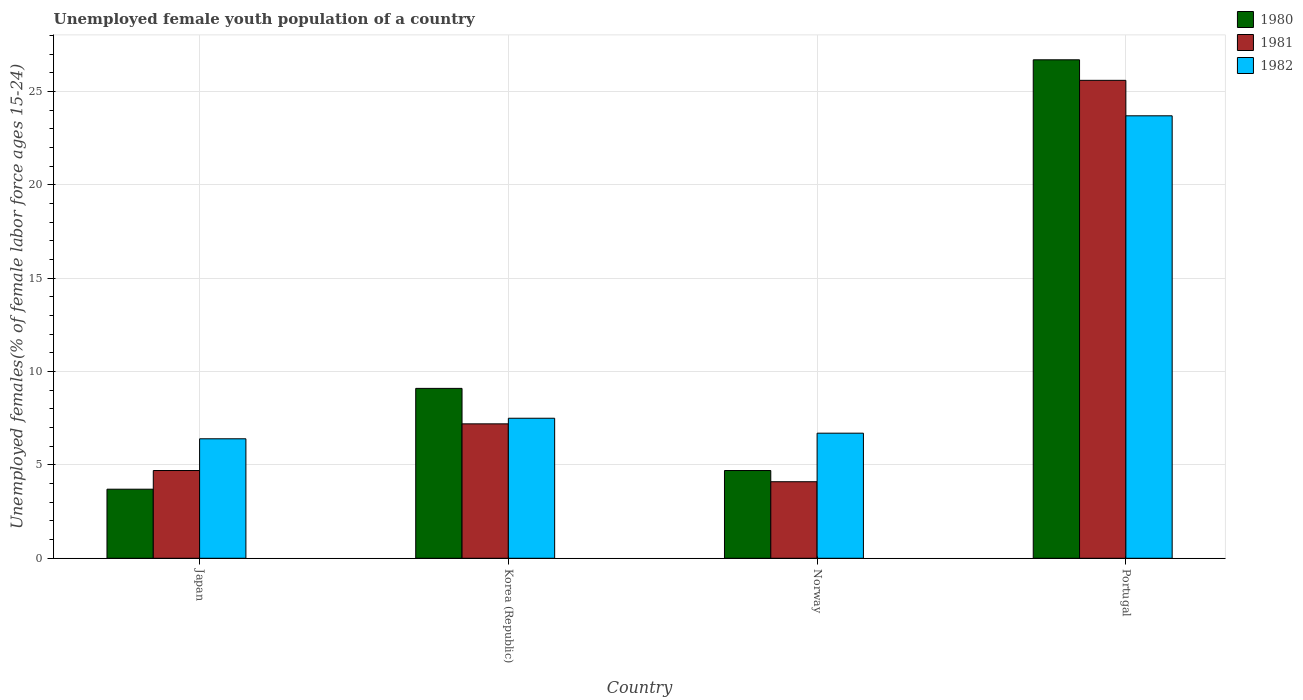How many different coloured bars are there?
Make the answer very short. 3. How many groups of bars are there?
Offer a very short reply. 4. Are the number of bars per tick equal to the number of legend labels?
Offer a very short reply. Yes. How many bars are there on the 2nd tick from the left?
Your response must be concise. 3. What is the percentage of unemployed female youth population in 1981 in Japan?
Provide a short and direct response. 4.7. Across all countries, what is the maximum percentage of unemployed female youth population in 1981?
Keep it short and to the point. 25.6. Across all countries, what is the minimum percentage of unemployed female youth population in 1982?
Offer a very short reply. 6.4. In which country was the percentage of unemployed female youth population in 1982 maximum?
Provide a short and direct response. Portugal. What is the total percentage of unemployed female youth population in 1981 in the graph?
Your answer should be very brief. 41.6. What is the difference between the percentage of unemployed female youth population in 1981 in Korea (Republic) and that in Portugal?
Keep it short and to the point. -18.4. What is the difference between the percentage of unemployed female youth population in 1982 in Norway and the percentage of unemployed female youth population in 1981 in Portugal?
Provide a short and direct response. -18.9. What is the average percentage of unemployed female youth population in 1980 per country?
Offer a very short reply. 11.05. What is the difference between the percentage of unemployed female youth population of/in 1980 and percentage of unemployed female youth population of/in 1981 in Portugal?
Offer a terse response. 1.1. In how many countries, is the percentage of unemployed female youth population in 1982 greater than 25 %?
Provide a short and direct response. 0. What is the ratio of the percentage of unemployed female youth population in 1982 in Norway to that in Portugal?
Ensure brevity in your answer.  0.28. Is the difference between the percentage of unemployed female youth population in 1980 in Japan and Norway greater than the difference between the percentage of unemployed female youth population in 1981 in Japan and Norway?
Make the answer very short. No. What is the difference between the highest and the second highest percentage of unemployed female youth population in 1981?
Provide a short and direct response. 20.9. What is the difference between the highest and the lowest percentage of unemployed female youth population in 1980?
Your answer should be very brief. 23. In how many countries, is the percentage of unemployed female youth population in 1980 greater than the average percentage of unemployed female youth population in 1980 taken over all countries?
Your answer should be compact. 1. What does the 1st bar from the right in Japan represents?
Ensure brevity in your answer.  1982. How many bars are there?
Make the answer very short. 12. Are all the bars in the graph horizontal?
Your response must be concise. No. What is the difference between two consecutive major ticks on the Y-axis?
Provide a short and direct response. 5. Does the graph contain any zero values?
Ensure brevity in your answer.  No. Where does the legend appear in the graph?
Ensure brevity in your answer.  Top right. What is the title of the graph?
Keep it short and to the point. Unemployed female youth population of a country. Does "1978" appear as one of the legend labels in the graph?
Offer a very short reply. No. What is the label or title of the X-axis?
Provide a short and direct response. Country. What is the label or title of the Y-axis?
Provide a short and direct response. Unemployed females(% of female labor force ages 15-24). What is the Unemployed females(% of female labor force ages 15-24) in 1980 in Japan?
Make the answer very short. 3.7. What is the Unemployed females(% of female labor force ages 15-24) in 1981 in Japan?
Provide a succinct answer. 4.7. What is the Unemployed females(% of female labor force ages 15-24) in 1982 in Japan?
Provide a short and direct response. 6.4. What is the Unemployed females(% of female labor force ages 15-24) of 1980 in Korea (Republic)?
Give a very brief answer. 9.1. What is the Unemployed females(% of female labor force ages 15-24) in 1981 in Korea (Republic)?
Ensure brevity in your answer.  7.2. What is the Unemployed females(% of female labor force ages 15-24) in 1980 in Norway?
Offer a very short reply. 4.7. What is the Unemployed females(% of female labor force ages 15-24) in 1981 in Norway?
Offer a terse response. 4.1. What is the Unemployed females(% of female labor force ages 15-24) in 1982 in Norway?
Make the answer very short. 6.7. What is the Unemployed females(% of female labor force ages 15-24) in 1980 in Portugal?
Provide a succinct answer. 26.7. What is the Unemployed females(% of female labor force ages 15-24) in 1981 in Portugal?
Your answer should be compact. 25.6. What is the Unemployed females(% of female labor force ages 15-24) in 1982 in Portugal?
Keep it short and to the point. 23.7. Across all countries, what is the maximum Unemployed females(% of female labor force ages 15-24) in 1980?
Ensure brevity in your answer.  26.7. Across all countries, what is the maximum Unemployed females(% of female labor force ages 15-24) of 1981?
Keep it short and to the point. 25.6. Across all countries, what is the maximum Unemployed females(% of female labor force ages 15-24) of 1982?
Provide a short and direct response. 23.7. Across all countries, what is the minimum Unemployed females(% of female labor force ages 15-24) of 1980?
Keep it short and to the point. 3.7. Across all countries, what is the minimum Unemployed females(% of female labor force ages 15-24) in 1981?
Keep it short and to the point. 4.1. Across all countries, what is the minimum Unemployed females(% of female labor force ages 15-24) in 1982?
Your answer should be very brief. 6.4. What is the total Unemployed females(% of female labor force ages 15-24) in 1980 in the graph?
Your answer should be compact. 44.2. What is the total Unemployed females(% of female labor force ages 15-24) of 1981 in the graph?
Your response must be concise. 41.6. What is the total Unemployed females(% of female labor force ages 15-24) in 1982 in the graph?
Ensure brevity in your answer.  44.3. What is the difference between the Unemployed females(% of female labor force ages 15-24) of 1981 in Japan and that in Korea (Republic)?
Your answer should be very brief. -2.5. What is the difference between the Unemployed females(% of female labor force ages 15-24) of 1982 in Japan and that in Korea (Republic)?
Offer a very short reply. -1.1. What is the difference between the Unemployed females(% of female labor force ages 15-24) of 1980 in Japan and that in Norway?
Offer a terse response. -1. What is the difference between the Unemployed females(% of female labor force ages 15-24) in 1981 in Japan and that in Norway?
Offer a terse response. 0.6. What is the difference between the Unemployed females(% of female labor force ages 15-24) of 1981 in Japan and that in Portugal?
Ensure brevity in your answer.  -20.9. What is the difference between the Unemployed females(% of female labor force ages 15-24) of 1982 in Japan and that in Portugal?
Your answer should be compact. -17.3. What is the difference between the Unemployed females(% of female labor force ages 15-24) of 1982 in Korea (Republic) and that in Norway?
Provide a short and direct response. 0.8. What is the difference between the Unemployed females(% of female labor force ages 15-24) in 1980 in Korea (Republic) and that in Portugal?
Keep it short and to the point. -17.6. What is the difference between the Unemployed females(% of female labor force ages 15-24) in 1981 in Korea (Republic) and that in Portugal?
Keep it short and to the point. -18.4. What is the difference between the Unemployed females(% of female labor force ages 15-24) in 1982 in Korea (Republic) and that in Portugal?
Offer a very short reply. -16.2. What is the difference between the Unemployed females(% of female labor force ages 15-24) of 1980 in Norway and that in Portugal?
Provide a succinct answer. -22. What is the difference between the Unemployed females(% of female labor force ages 15-24) in 1981 in Norway and that in Portugal?
Keep it short and to the point. -21.5. What is the difference between the Unemployed females(% of female labor force ages 15-24) of 1980 in Japan and the Unemployed females(% of female labor force ages 15-24) of 1981 in Korea (Republic)?
Make the answer very short. -3.5. What is the difference between the Unemployed females(% of female labor force ages 15-24) of 1980 in Japan and the Unemployed females(% of female labor force ages 15-24) of 1982 in Korea (Republic)?
Ensure brevity in your answer.  -3.8. What is the difference between the Unemployed females(% of female labor force ages 15-24) in 1980 in Japan and the Unemployed females(% of female labor force ages 15-24) in 1982 in Norway?
Ensure brevity in your answer.  -3. What is the difference between the Unemployed females(% of female labor force ages 15-24) of 1980 in Japan and the Unemployed females(% of female labor force ages 15-24) of 1981 in Portugal?
Keep it short and to the point. -21.9. What is the difference between the Unemployed females(% of female labor force ages 15-24) in 1980 in Japan and the Unemployed females(% of female labor force ages 15-24) in 1982 in Portugal?
Offer a terse response. -20. What is the difference between the Unemployed females(% of female labor force ages 15-24) of 1981 in Japan and the Unemployed females(% of female labor force ages 15-24) of 1982 in Portugal?
Provide a short and direct response. -19. What is the difference between the Unemployed females(% of female labor force ages 15-24) of 1980 in Korea (Republic) and the Unemployed females(% of female labor force ages 15-24) of 1981 in Norway?
Make the answer very short. 5. What is the difference between the Unemployed females(% of female labor force ages 15-24) of 1980 in Korea (Republic) and the Unemployed females(% of female labor force ages 15-24) of 1982 in Norway?
Your answer should be very brief. 2.4. What is the difference between the Unemployed females(% of female labor force ages 15-24) of 1981 in Korea (Republic) and the Unemployed females(% of female labor force ages 15-24) of 1982 in Norway?
Keep it short and to the point. 0.5. What is the difference between the Unemployed females(% of female labor force ages 15-24) of 1980 in Korea (Republic) and the Unemployed females(% of female labor force ages 15-24) of 1981 in Portugal?
Offer a terse response. -16.5. What is the difference between the Unemployed females(% of female labor force ages 15-24) of 1980 in Korea (Republic) and the Unemployed females(% of female labor force ages 15-24) of 1982 in Portugal?
Your answer should be very brief. -14.6. What is the difference between the Unemployed females(% of female labor force ages 15-24) of 1981 in Korea (Republic) and the Unemployed females(% of female labor force ages 15-24) of 1982 in Portugal?
Ensure brevity in your answer.  -16.5. What is the difference between the Unemployed females(% of female labor force ages 15-24) in 1980 in Norway and the Unemployed females(% of female labor force ages 15-24) in 1981 in Portugal?
Offer a terse response. -20.9. What is the difference between the Unemployed females(% of female labor force ages 15-24) of 1981 in Norway and the Unemployed females(% of female labor force ages 15-24) of 1982 in Portugal?
Keep it short and to the point. -19.6. What is the average Unemployed females(% of female labor force ages 15-24) of 1980 per country?
Make the answer very short. 11.05. What is the average Unemployed females(% of female labor force ages 15-24) in 1982 per country?
Your answer should be very brief. 11.07. What is the difference between the Unemployed females(% of female labor force ages 15-24) of 1981 and Unemployed females(% of female labor force ages 15-24) of 1982 in Japan?
Offer a terse response. -1.7. What is the difference between the Unemployed females(% of female labor force ages 15-24) in 1980 and Unemployed females(% of female labor force ages 15-24) in 1981 in Korea (Republic)?
Give a very brief answer. 1.9. What is the difference between the Unemployed females(% of female labor force ages 15-24) of 1980 and Unemployed females(% of female labor force ages 15-24) of 1981 in Norway?
Keep it short and to the point. 0.6. What is the difference between the Unemployed females(% of female labor force ages 15-24) in 1980 and Unemployed females(% of female labor force ages 15-24) in 1981 in Portugal?
Make the answer very short. 1.1. What is the difference between the Unemployed females(% of female labor force ages 15-24) in 1981 and Unemployed females(% of female labor force ages 15-24) in 1982 in Portugal?
Offer a very short reply. 1.9. What is the ratio of the Unemployed females(% of female labor force ages 15-24) of 1980 in Japan to that in Korea (Republic)?
Keep it short and to the point. 0.41. What is the ratio of the Unemployed females(% of female labor force ages 15-24) in 1981 in Japan to that in Korea (Republic)?
Your answer should be compact. 0.65. What is the ratio of the Unemployed females(% of female labor force ages 15-24) in 1982 in Japan to that in Korea (Republic)?
Provide a succinct answer. 0.85. What is the ratio of the Unemployed females(% of female labor force ages 15-24) in 1980 in Japan to that in Norway?
Make the answer very short. 0.79. What is the ratio of the Unemployed females(% of female labor force ages 15-24) of 1981 in Japan to that in Norway?
Your answer should be very brief. 1.15. What is the ratio of the Unemployed females(% of female labor force ages 15-24) of 1982 in Japan to that in Norway?
Your answer should be very brief. 0.96. What is the ratio of the Unemployed females(% of female labor force ages 15-24) of 1980 in Japan to that in Portugal?
Offer a terse response. 0.14. What is the ratio of the Unemployed females(% of female labor force ages 15-24) in 1981 in Japan to that in Portugal?
Make the answer very short. 0.18. What is the ratio of the Unemployed females(% of female labor force ages 15-24) in 1982 in Japan to that in Portugal?
Give a very brief answer. 0.27. What is the ratio of the Unemployed females(% of female labor force ages 15-24) in 1980 in Korea (Republic) to that in Norway?
Make the answer very short. 1.94. What is the ratio of the Unemployed females(% of female labor force ages 15-24) of 1981 in Korea (Republic) to that in Norway?
Your response must be concise. 1.76. What is the ratio of the Unemployed females(% of female labor force ages 15-24) of 1982 in Korea (Republic) to that in Norway?
Make the answer very short. 1.12. What is the ratio of the Unemployed females(% of female labor force ages 15-24) of 1980 in Korea (Republic) to that in Portugal?
Ensure brevity in your answer.  0.34. What is the ratio of the Unemployed females(% of female labor force ages 15-24) in 1981 in Korea (Republic) to that in Portugal?
Your response must be concise. 0.28. What is the ratio of the Unemployed females(% of female labor force ages 15-24) in 1982 in Korea (Republic) to that in Portugal?
Offer a very short reply. 0.32. What is the ratio of the Unemployed females(% of female labor force ages 15-24) in 1980 in Norway to that in Portugal?
Your answer should be compact. 0.18. What is the ratio of the Unemployed females(% of female labor force ages 15-24) of 1981 in Norway to that in Portugal?
Make the answer very short. 0.16. What is the ratio of the Unemployed females(% of female labor force ages 15-24) of 1982 in Norway to that in Portugal?
Provide a succinct answer. 0.28. What is the difference between the highest and the lowest Unemployed females(% of female labor force ages 15-24) of 1980?
Your response must be concise. 23. What is the difference between the highest and the lowest Unemployed females(% of female labor force ages 15-24) of 1981?
Your response must be concise. 21.5. What is the difference between the highest and the lowest Unemployed females(% of female labor force ages 15-24) of 1982?
Ensure brevity in your answer.  17.3. 